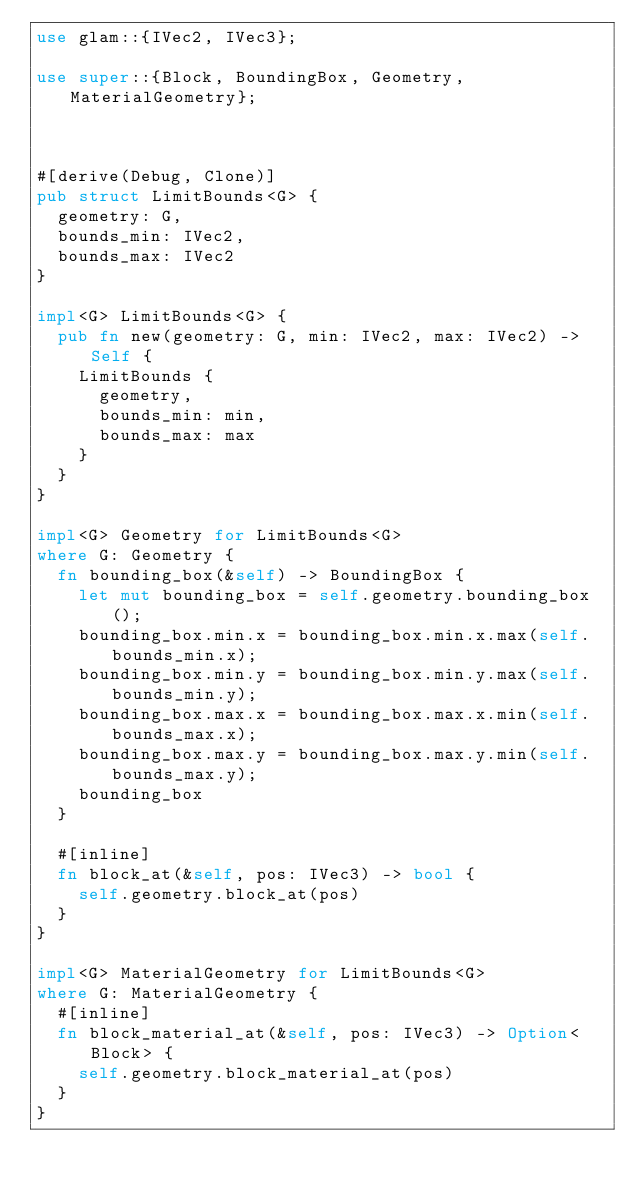<code> <loc_0><loc_0><loc_500><loc_500><_Rust_>use glam::{IVec2, IVec3};

use super::{Block, BoundingBox, Geometry, MaterialGeometry};



#[derive(Debug, Clone)]
pub struct LimitBounds<G> {
  geometry: G,
  bounds_min: IVec2,
  bounds_max: IVec2
}

impl<G> LimitBounds<G> {
  pub fn new(geometry: G, min: IVec2, max: IVec2) -> Self {
    LimitBounds {
      geometry,
      bounds_min: min,
      bounds_max: max
    }
  }
}

impl<G> Geometry for LimitBounds<G>
where G: Geometry {
  fn bounding_box(&self) -> BoundingBox {
    let mut bounding_box = self.geometry.bounding_box();
    bounding_box.min.x = bounding_box.min.x.max(self.bounds_min.x);
    bounding_box.min.y = bounding_box.min.y.max(self.bounds_min.y);
    bounding_box.max.x = bounding_box.max.x.min(self.bounds_max.x);
    bounding_box.max.y = bounding_box.max.y.min(self.bounds_max.y);
    bounding_box
  }

  #[inline]
  fn block_at(&self, pos: IVec3) -> bool {
    self.geometry.block_at(pos)
  }
}

impl<G> MaterialGeometry for LimitBounds<G>
where G: MaterialGeometry {
  #[inline]
  fn block_material_at(&self, pos: IVec3) -> Option<Block> {
    self.geometry.block_material_at(pos)
  }
}
</code> 